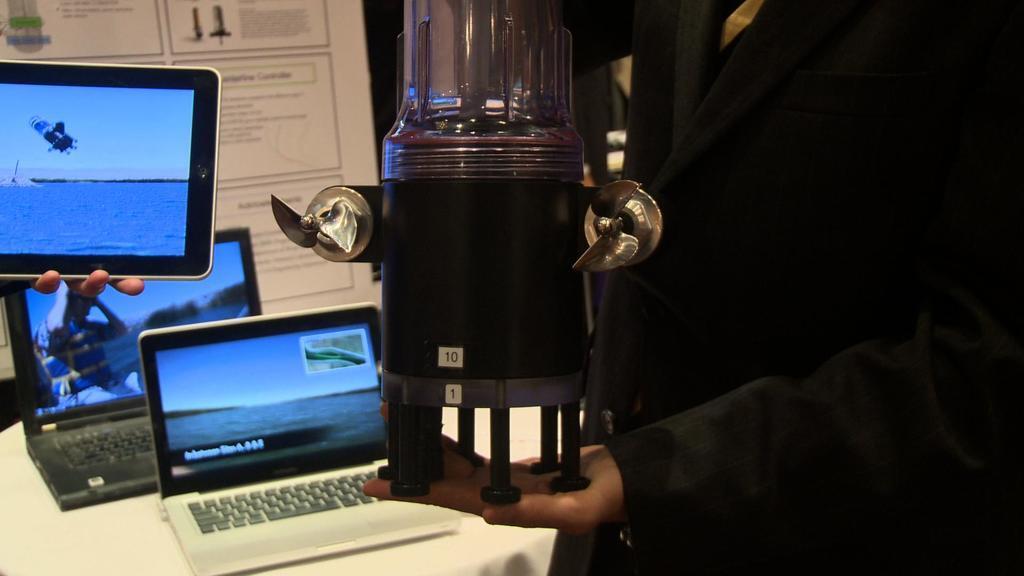How would you summarize this image in a sentence or two? In this image we can see a person holding an object, there is a table, on the table, we can see the laptops, also we can see a person's hand holding a tab, in the background, it looks like a board, on the board, we can see some text and images. 